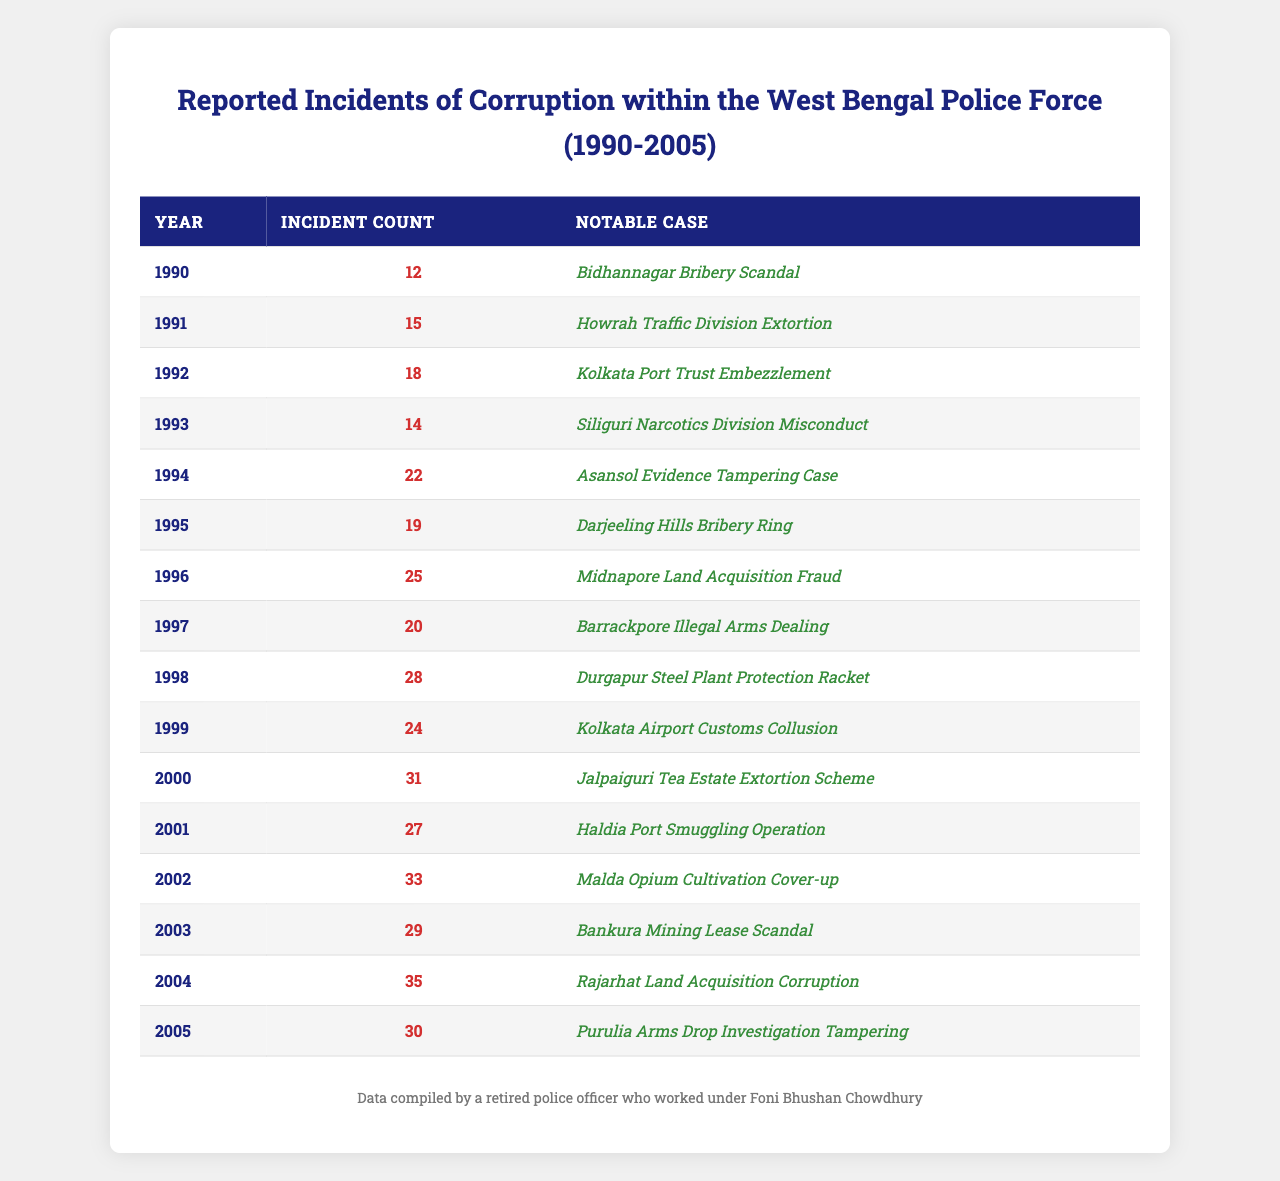What was the highest number of reported corruption incidents in a single year? By inspection of the table, the year 2004 has the highest count with 35 incidents reported.
Answer: 35 In which year was the "Malda Opium Cultivation Cover-up" notable case reported? The table shows that this notable case was reported in 2002, as indicated in the corresponding row.
Answer: 2002 What was the average number of incidents of corruption from 1990 to 2005? To find the average, sum the total incidents: 12 + 15 + 18 + 14 + 22 + 19 + 25 + 20 + 28 + 24 + 31 + 27 + 33 + 29 + 35 + 30 =  388. There are 16 years, so the average is 388 / 16 = 24.25.
Answer: 24.25 Which year had the least number of reported incidents, and what was the count? The year 1990 had the least incidents with 12 reported. This can be confirmed by examining the table's incident counts.
Answer: 1990, 12 Was there a notable case in 1993? Yes, there was a notable case titled "Siliguri Narcotics Division Misconduct" in 1993 according to the table.
Answer: Yes How many incidents were reported in the year following the highest number of incidents? The highest number of incidents was in 2004 with 35. The following year, 2005, had 30 incidents. The values can be found by reviewing the rows for these years.
Answer: 30 Which notable case from 1998 had more incidents reported than the notable case from 1997? In 1998, "Durgapur Steel Plant Protection Racket" had 28 incidents, while 1997's case, "Barrackpore Illegal Arms Dealing," had 20 incidents. Since 28 is greater than 20, this condition is satisfied.
Answer: Yes How many more incidents were reported in 2002 than in 2000? In 2002, there were 33 incidents while in 2000, there were 31 incidents. The difference is 33 - 31 = 2.
Answer: 2 Identify the year with a notable case related to "Bribery" and provide the incident count for that year. The years 1990 and 1995 both have notable cases related to bribery ("Bidhannagar Bribery Scandal" and "Darjeeling Hills Bribery Ring"). The incident counts are 12 and 19 respectively.
Answer: 1990 (12), 1995 (19) In which year did the incidents first exceed 30 counts? The first occurrence of incidents exceeding 30 was in the year 2000, where 31 incidents were reported. This can be confirmed by reviewing the tables progressively from the start.
Answer: 2000 